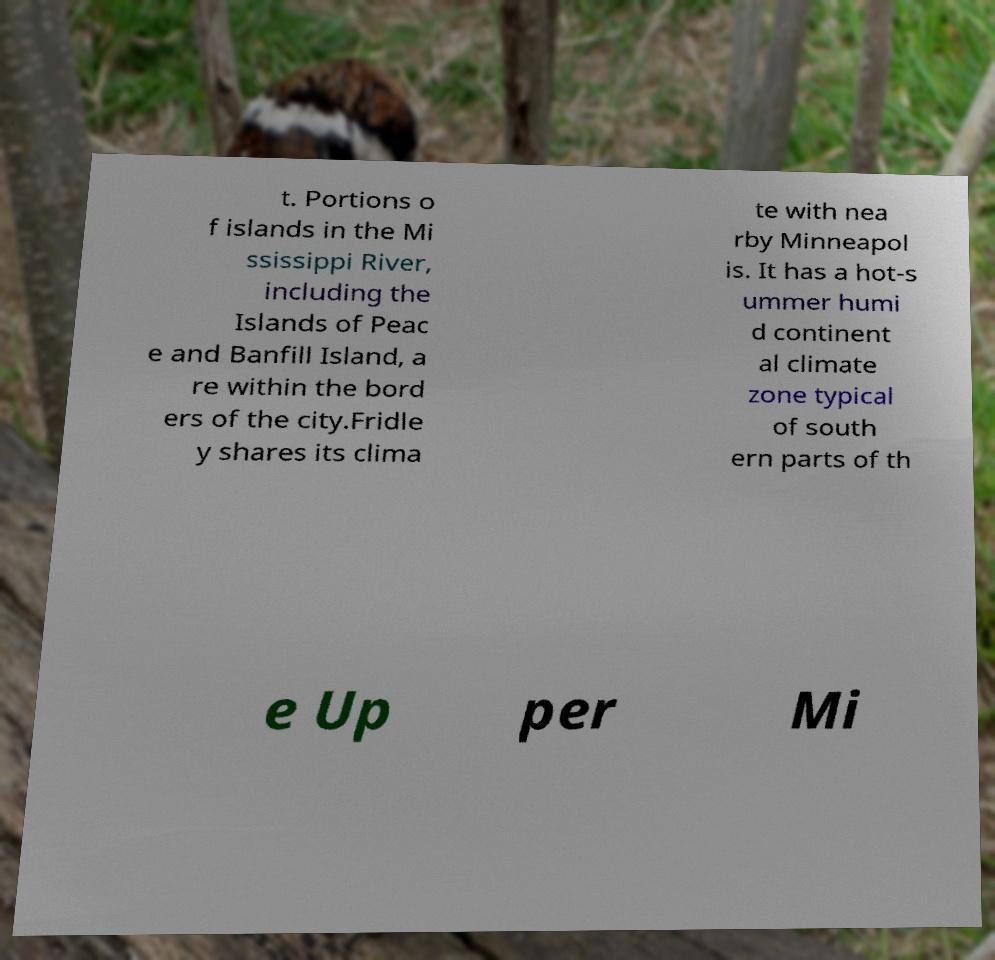Please read and relay the text visible in this image. What does it say? t. Portions o f islands in the Mi ssissippi River, including the Islands of Peac e and Banfill Island, a re within the bord ers of the city.Fridle y shares its clima te with nea rby Minneapol is. It has a hot-s ummer humi d continent al climate zone typical of south ern parts of th e Up per Mi 